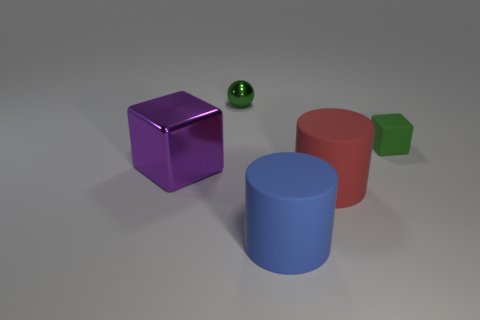Add 3 purple things. How many objects exist? 8 Subtract all blocks. How many objects are left? 3 Add 4 large things. How many large things are left? 7 Add 2 big purple matte blocks. How many big purple matte blocks exist? 2 Subtract 0 gray cubes. How many objects are left? 5 Subtract all brown spheres. Subtract all large blue matte things. How many objects are left? 4 